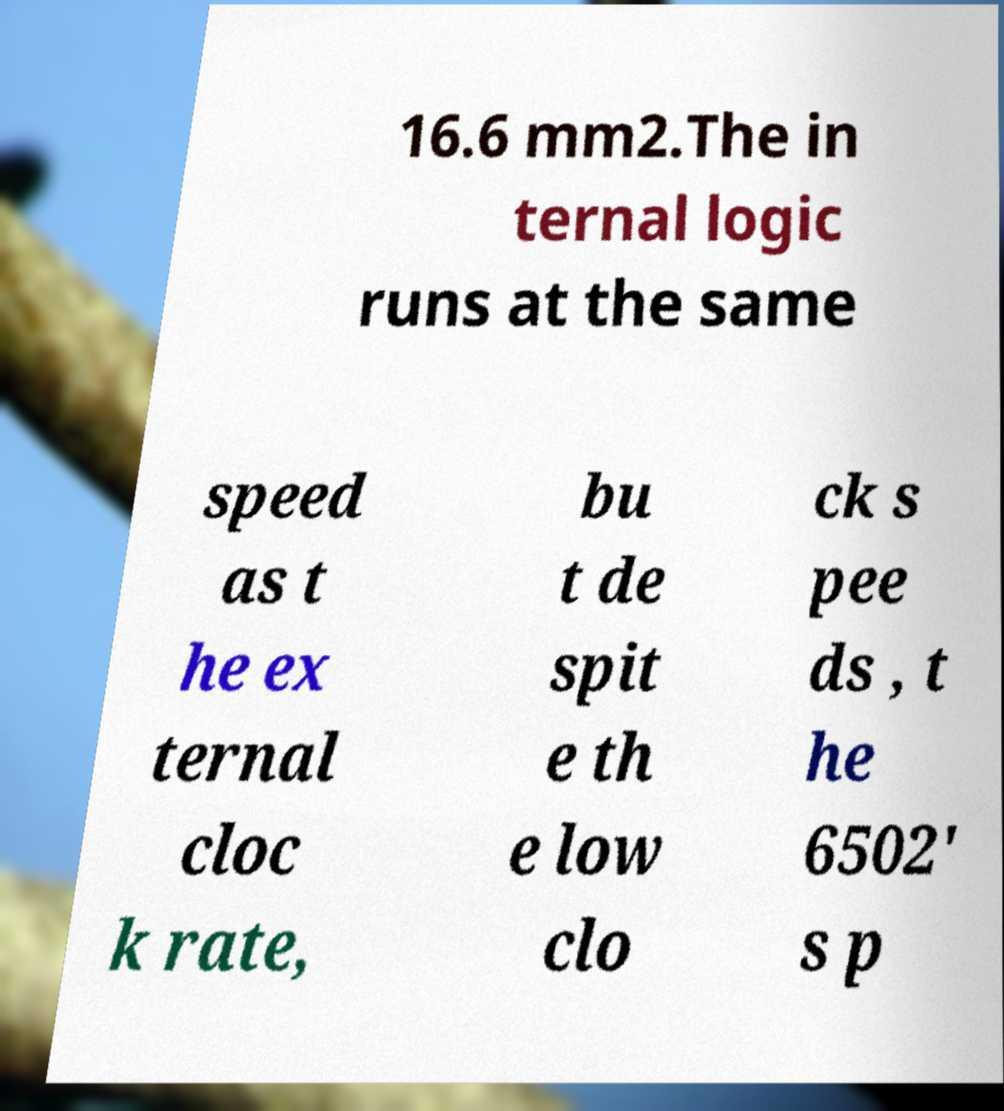What messages or text are displayed in this image? I need them in a readable, typed format. 16.6 mm2.The in ternal logic runs at the same speed as t he ex ternal cloc k rate, bu t de spit e th e low clo ck s pee ds , t he 6502' s p 